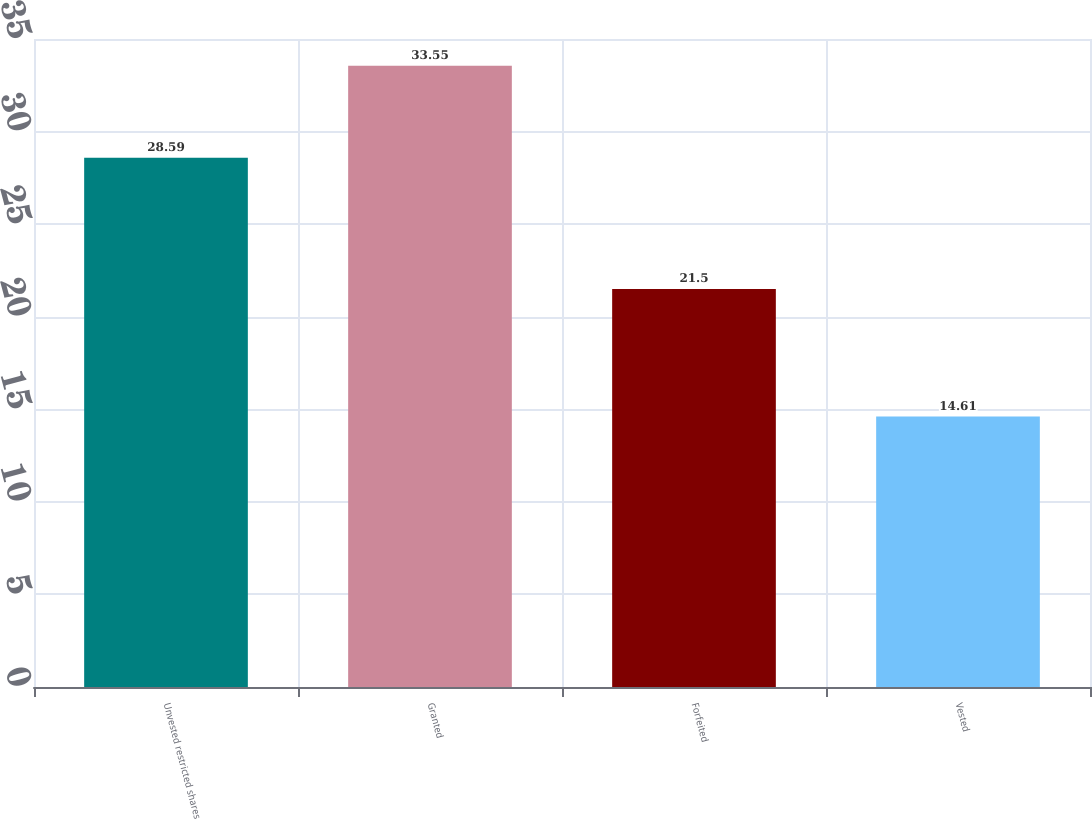Convert chart. <chart><loc_0><loc_0><loc_500><loc_500><bar_chart><fcel>Unvested restricted shares<fcel>Granted<fcel>Forfeited<fcel>Vested<nl><fcel>28.59<fcel>33.55<fcel>21.5<fcel>14.61<nl></chart> 